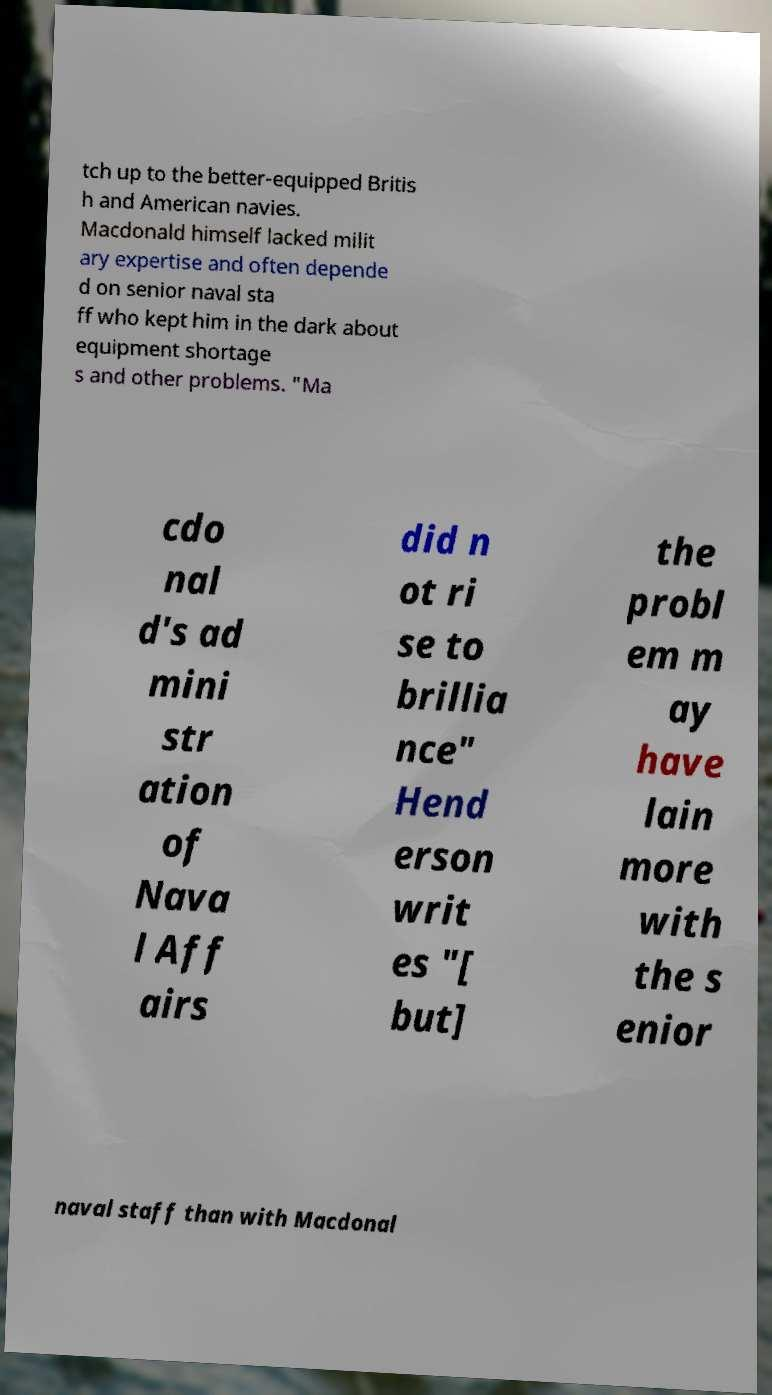Could you assist in decoding the text presented in this image and type it out clearly? tch up to the better-equipped Britis h and American navies. Macdonald himself lacked milit ary expertise and often depende d on senior naval sta ff who kept him in the dark about equipment shortage s and other problems. "Ma cdo nal d's ad mini str ation of Nava l Aff airs did n ot ri se to brillia nce" Hend erson writ es "[ but] the probl em m ay have lain more with the s enior naval staff than with Macdonal 